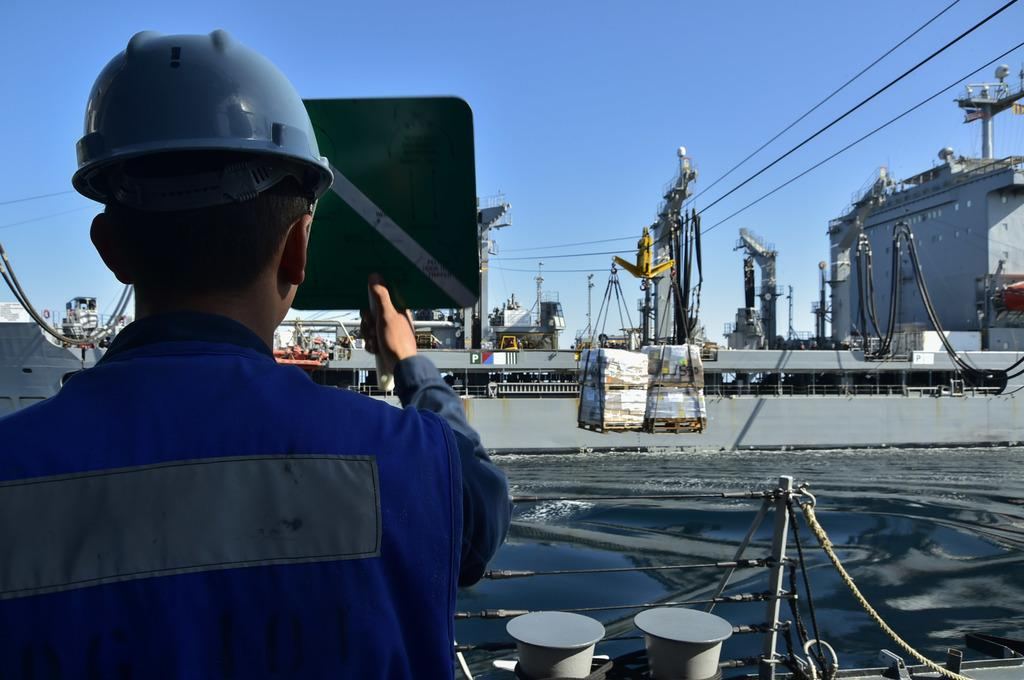What is happening in the image? There are ships sailing on a sea in the image. Can you describe the person in the image? There is a man standing on the left side of the image. What is the man holding in his hand? The man is holding a board in his hand. Can you see any visible veins on the ships in the image? There are no visible veins on the ships in the image, as ships do not have veins. Is there a band playing music in the image? There is no band playing music in the image; it only features ships sailing on a sea and a man holding a board. 